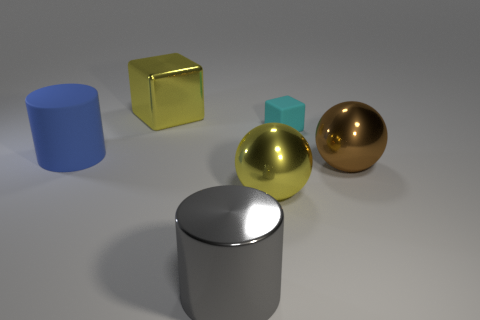Add 1 brown shiny balls. How many objects exist? 7 Subtract all cylinders. How many objects are left? 4 Subtract all gray rubber cylinders. Subtract all large metal objects. How many objects are left? 2 Add 5 cylinders. How many cylinders are left? 7 Add 6 small brown matte blocks. How many small brown matte blocks exist? 6 Subtract 1 gray cylinders. How many objects are left? 5 